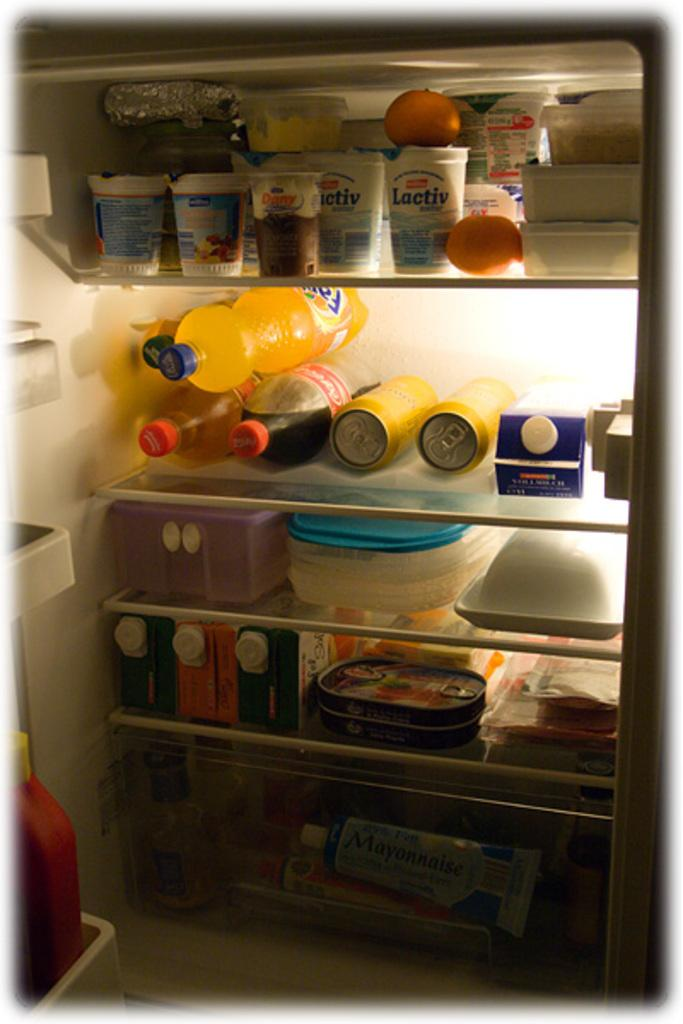<image>
Describe the image concisely. Proactiv and Dany yogurts sit on the top shelf of the fridge. 